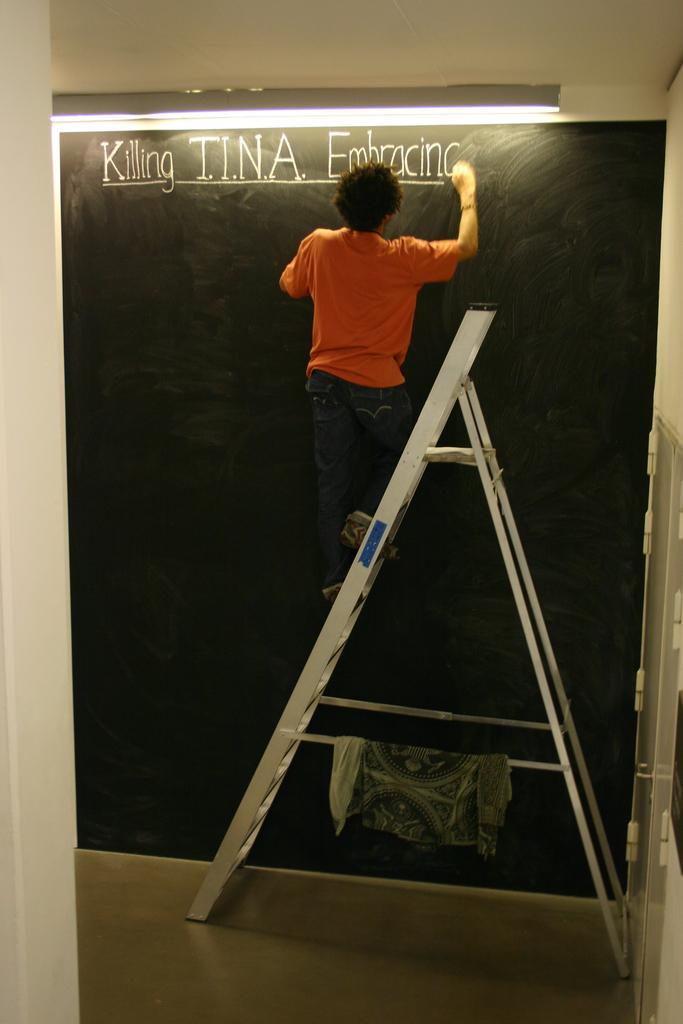Can you describe this image briefly? In this picture there is a boy wearing orange color t-shirt standing on the silver ladder and writing something on the blackboard. 